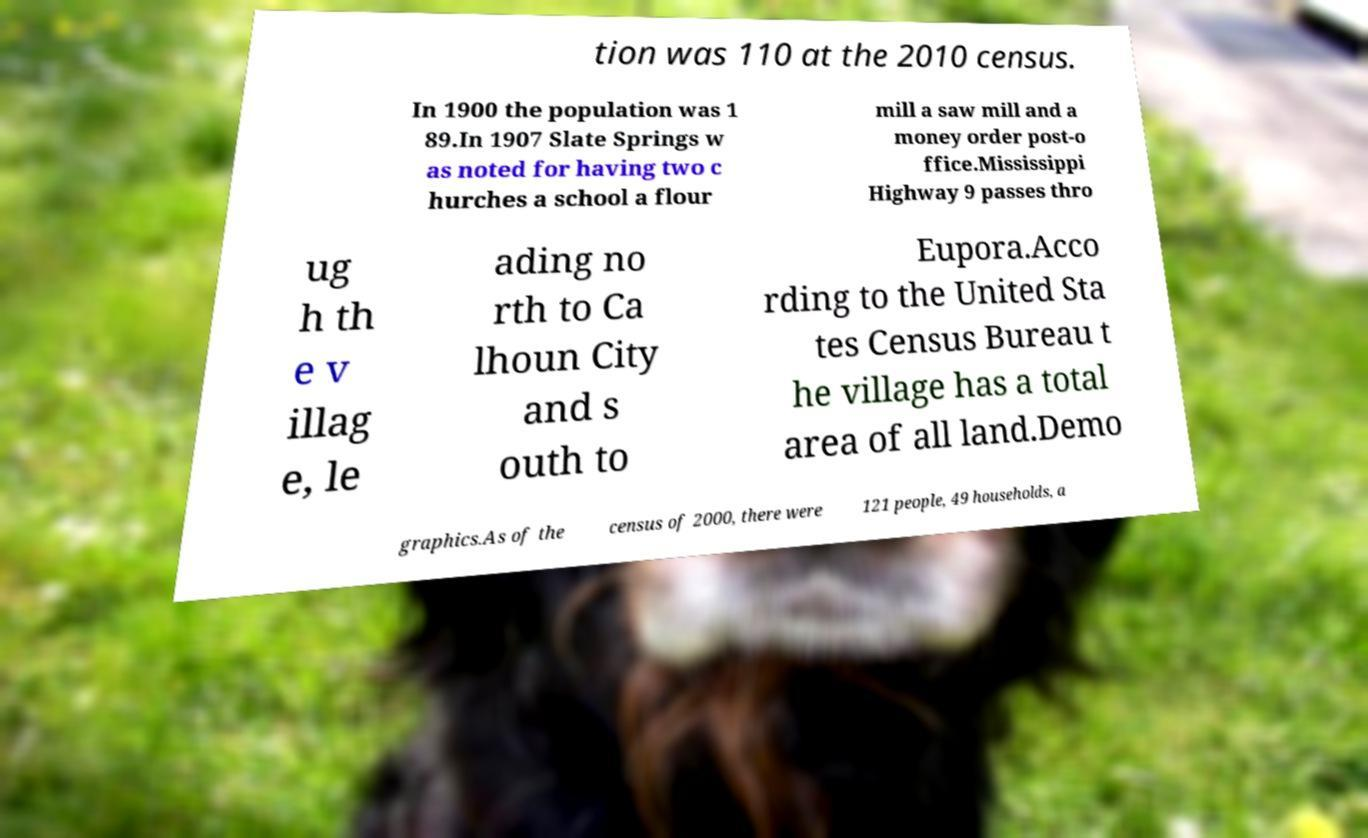What messages or text are displayed in this image? I need them in a readable, typed format. tion was 110 at the 2010 census. In 1900 the population was 1 89.In 1907 Slate Springs w as noted for having two c hurches a school a flour mill a saw mill and a money order post-o ffice.Mississippi Highway 9 passes thro ug h th e v illag e, le ading no rth to Ca lhoun City and s outh to Eupora.Acco rding to the United Sta tes Census Bureau t he village has a total area of all land.Demo graphics.As of the census of 2000, there were 121 people, 49 households, a 